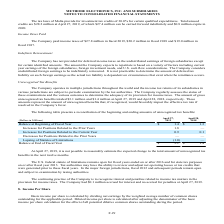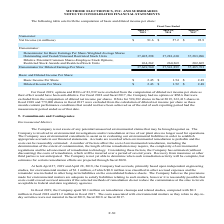According to Methode Electronics's financial document, How is basic income per share calculated? by dividing net earnings by the weighted average number of common shares outstanding for the applicable period.. The document states: "Basic income per share is calculated by dividing net earnings by the weighted average number of common shares outstanding for the applicable period. D..." Also, What amount of RSUs were excluded from the computation of diluted net income per share? According to the financial document, 83,939. The relevant text states: "For fiscal 2019, options and RSUs of 83,939 were excluded from the computation of diluted net income per share as..." Also, What were the RSAs in 2019, 2018 and 2017 respectively? The document contains multiple relevant values: 594,382, 363,413, 779,000. From the document: "in fiscal 2019, 363,413 shares in fiscal 2018 and 779,000 shares in fiscal 2017 were excluded from the calculation of diluted net income per share as ..." Also, can you calculate: What was the change in the Net income from 2018 to 2019? Based on the calculation: 91.6 - 57.2, the result is 34.4 (in millions). This is based on the information: "Numerator: Net Income (in millions) $ 91.6 $ 57.2 $ 92.9 Numerator: Net Income (in millions) $ 91.6 $ 57.2 $ 92.9..." The key data points involved are: 57.2, 91.6. Also, can you calculate: What is the average Outstanding and Vested/Unissued Restricted Stock Units for 2017-2019? To answer this question, I need to perform calculations using the financial data. The calculation is: (37,405,298 + 37,281,630 + 37,283,096) / 3, which equals 37323341.33. This is based on the information: "Vested/Unissued Restricted Stock Units 37,405,298 37,281,630 37,283,096 sued Restricted Stock Units 37,405,298 37,281,630 37,283,096 anding and Vested/Unissued Restricted Stock Units 37,405,298 37,281..." The key data points involved are: 37,281,630, 37,283,096, 37,405,298. Additionally, In which year was Basic Income Per Share less than 2.0? According to the financial document, 2018. The relevant text states: "8 million in fiscal 2019, $20.2 million in fiscal 2018 and $19.0 million in..." 